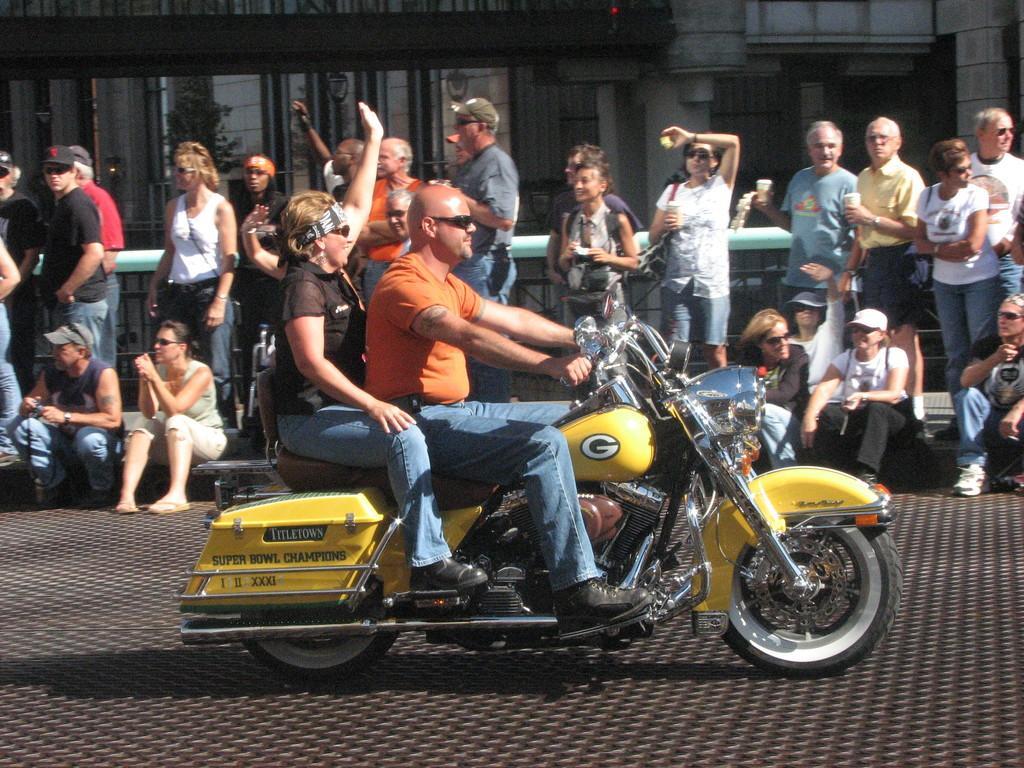Please provide a concise description of this image. As we can see in the image there are buildings, few people standing and sitting and in the front there is a motor cycle. 